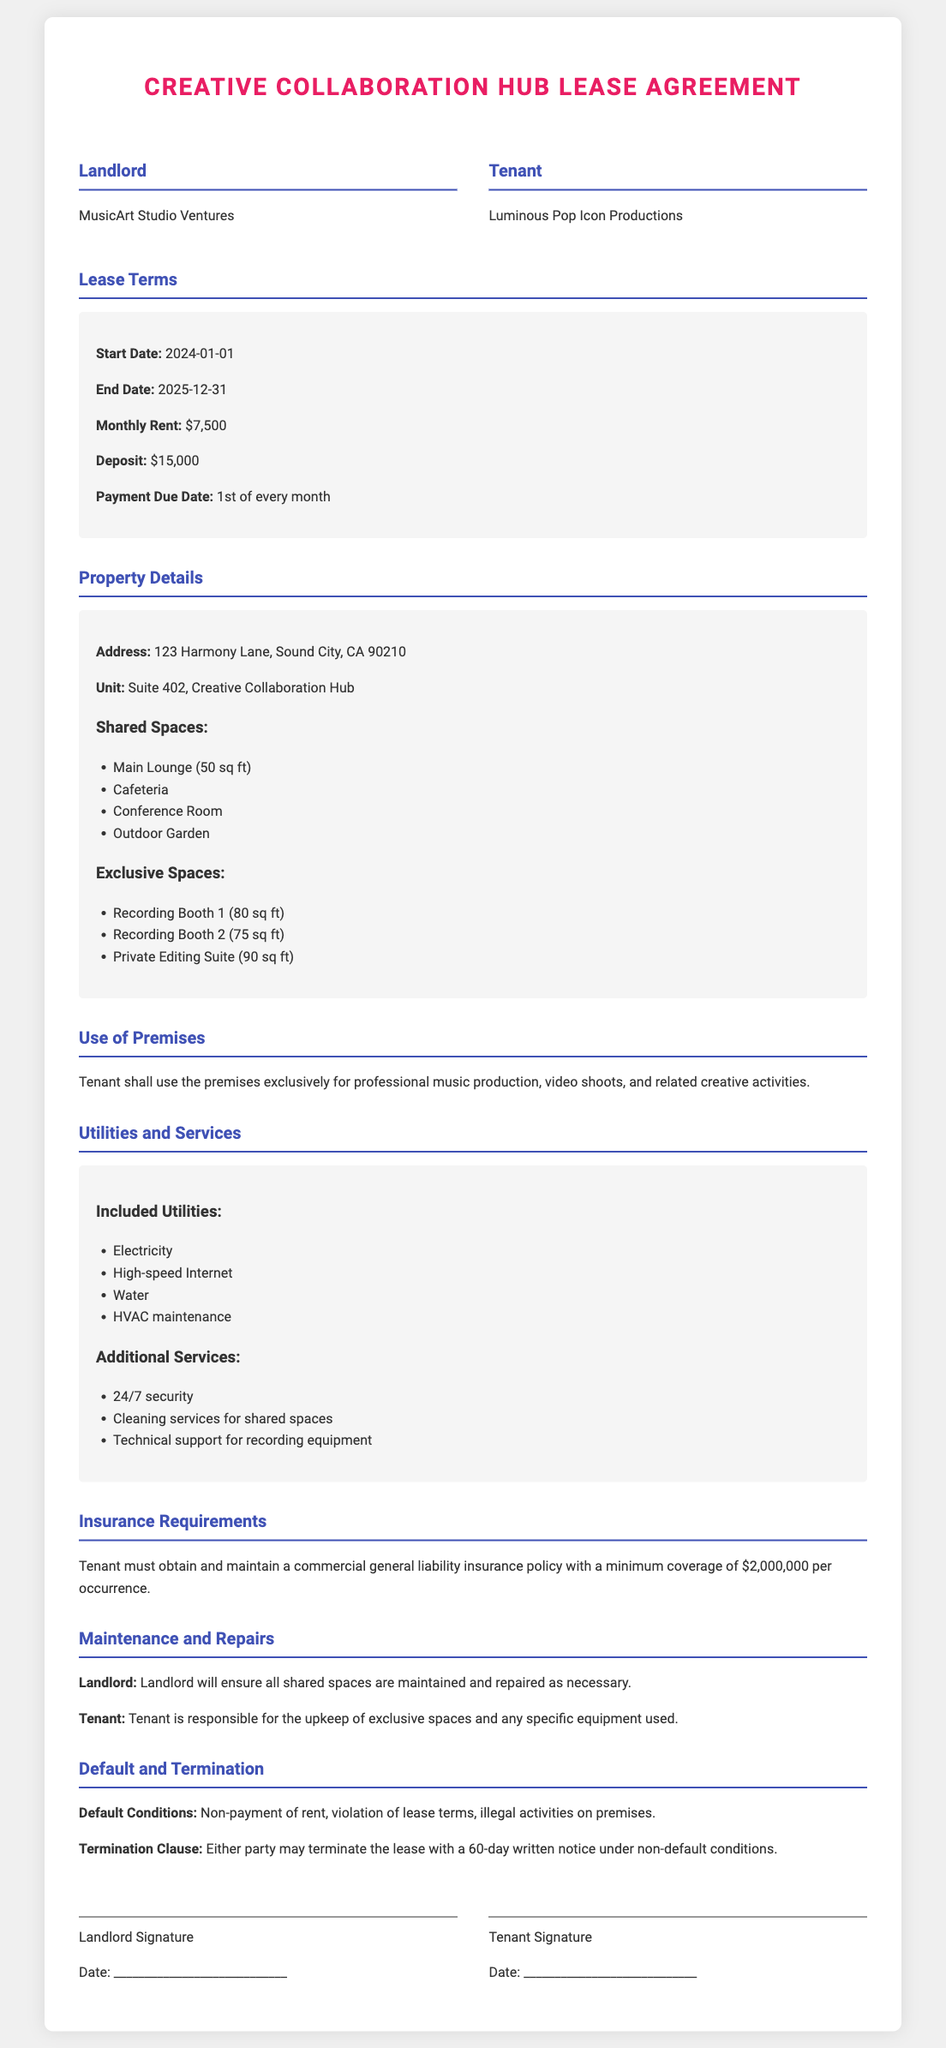What is the start date of the lease? The start date of the lease is specified in the lease terms section of the document.
Answer: 2024-01-01 What is the monthly rent amount? The monthly rent can be found in the lease terms section of the document.
Answer: $7,500 How much is the security deposit? The deposit amount is detailed in the lease terms.
Answer: $15,000 What is the minimum liability insurance coverage required? The insurance requirements state the minimum coverage amount needed.
Answer: $2,000,000 What is the address of the premises? The address is provided in the property details section of the document.
Answer: 123 Harmony Lane, Sound City, CA 90210 Which exclusive space has the largest area? By comparing the sizes of the exclusive spaces listed, the one with the largest area can be determined.
Answer: Private Editing Suite (90 sq ft) How long is the lease duration? The lease duration is calculated from the start date to the end date mentioned in the lease terms.
Answer: 2 years What is required for the termination of the lease? The termination clause describes the conditions needed for ending the lease.
Answer: 60-day written notice Which party is responsible for maintaining shared spaces? The maintenance responsibilities are explained in the maintenance and repairs section.
Answer: Landlord 